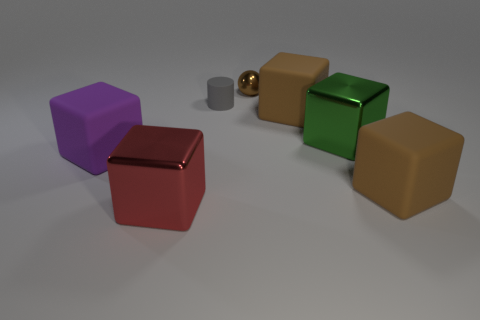Subtract all shiny cubes. How many cubes are left? 3 Subtract all yellow spheres. How many brown blocks are left? 2 Add 3 brown balls. How many objects exist? 10 Subtract all purple cubes. How many cubes are left? 4 Subtract all cylinders. How many objects are left? 6 Subtract 1 purple cubes. How many objects are left? 6 Subtract all red spheres. Subtract all yellow blocks. How many spheres are left? 1 Subtract all small gray matte cylinders. Subtract all small rubber cylinders. How many objects are left? 5 Add 5 brown shiny balls. How many brown shiny balls are left? 6 Add 6 gray metallic cylinders. How many gray metallic cylinders exist? 6 